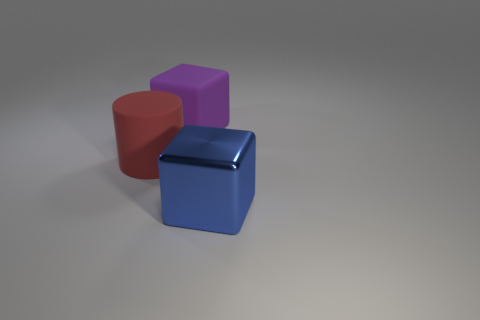If the shadowing in the image reflects a light source, where do you think it's coming from? Observing the shadows cast by the objects, we can deduce that the light source is positioned above and to the left of the scene. The shadows angle toward the bottom right, suggesting the light is hitting the objects from the upper left, illuminating the scene and creating a soft shadow gradient on the ground. 